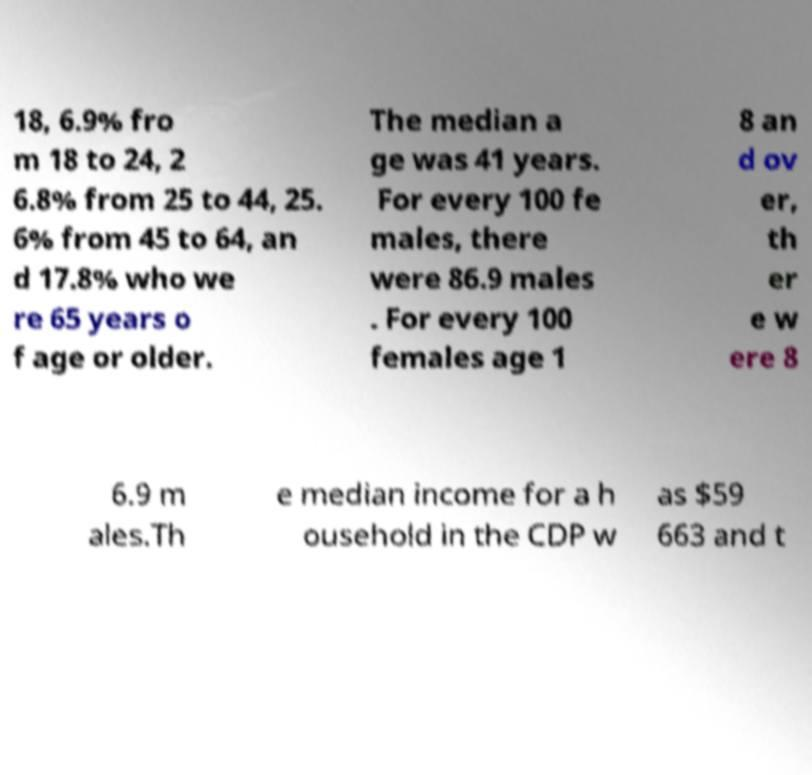Could you assist in decoding the text presented in this image and type it out clearly? 18, 6.9% fro m 18 to 24, 2 6.8% from 25 to 44, 25. 6% from 45 to 64, an d 17.8% who we re 65 years o f age or older. The median a ge was 41 years. For every 100 fe males, there were 86.9 males . For every 100 females age 1 8 an d ov er, th er e w ere 8 6.9 m ales.Th e median income for a h ousehold in the CDP w as $59 663 and t 